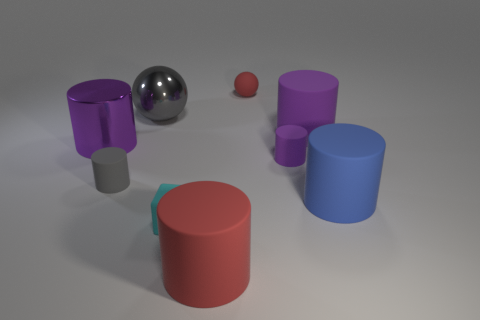There is a matte object that is the same color as the tiny rubber ball; what size is it?
Your answer should be compact. Large. What is the material of the large purple thing to the left of the red rubber object behind the gray shiny thing?
Your answer should be very brief. Metal. There is a big cylinder to the right of the big rubber thing that is behind the tiny object on the right side of the tiny red ball; what color is it?
Keep it short and to the point. Blue. Is the rubber block the same color as the large metal sphere?
Make the answer very short. No. How many purple things are the same size as the gray matte cylinder?
Offer a very short reply. 1. Are there more purple metal cylinders that are behind the small cyan cube than big blue rubber objects on the left side of the small purple matte object?
Give a very brief answer. Yes. The tiny rubber cylinder that is to the left of the ball that is right of the matte block is what color?
Offer a terse response. Gray. Does the big red cylinder have the same material as the big gray sphere?
Ensure brevity in your answer.  No. Are there any purple shiny objects of the same shape as the large gray thing?
Your answer should be very brief. No. Is the color of the large rubber thing behind the large shiny cylinder the same as the large metallic cylinder?
Give a very brief answer. Yes. 